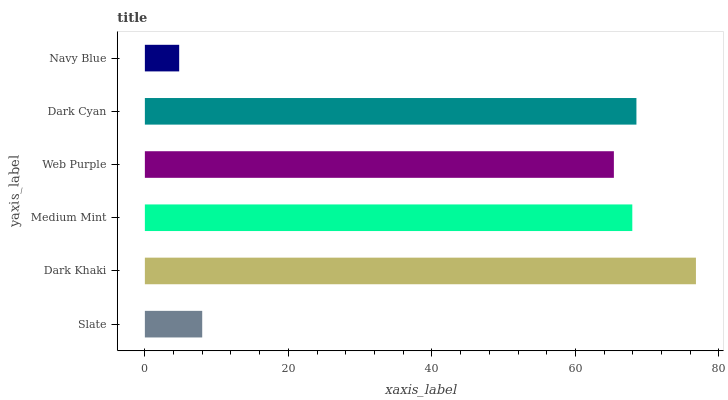Is Navy Blue the minimum?
Answer yes or no. Yes. Is Dark Khaki the maximum?
Answer yes or no. Yes. Is Medium Mint the minimum?
Answer yes or no. No. Is Medium Mint the maximum?
Answer yes or no. No. Is Dark Khaki greater than Medium Mint?
Answer yes or no. Yes. Is Medium Mint less than Dark Khaki?
Answer yes or no. Yes. Is Medium Mint greater than Dark Khaki?
Answer yes or no. No. Is Dark Khaki less than Medium Mint?
Answer yes or no. No. Is Medium Mint the high median?
Answer yes or no. Yes. Is Web Purple the low median?
Answer yes or no. Yes. Is Web Purple the high median?
Answer yes or no. No. Is Navy Blue the low median?
Answer yes or no. No. 